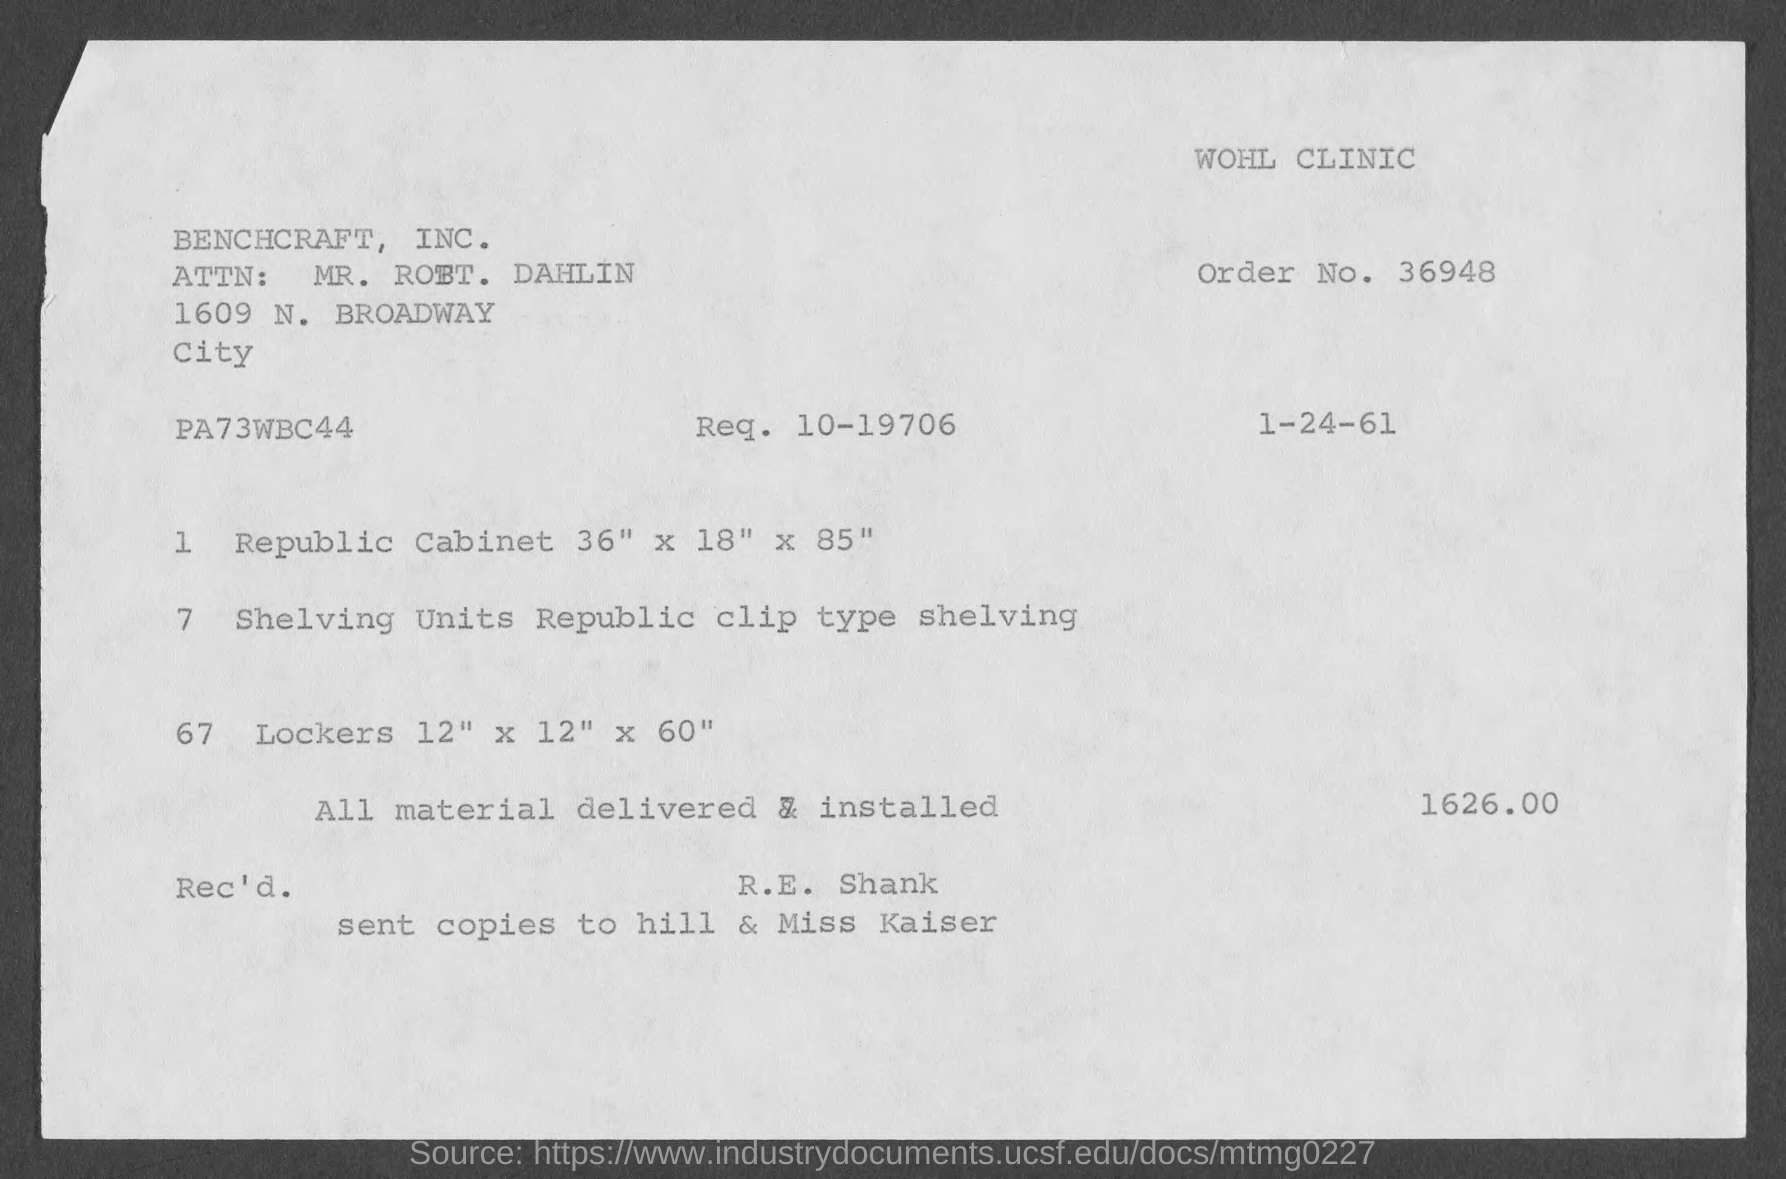What is the date mentioned in the invoice?
Give a very brief answer. 1-24-61. What is the Req. No. given in the invoice?
Your answer should be very brief. 10-19706. Which company is raising the invoice?
Offer a terse response. BENCHCRAFT, INC. What is the total invoice amount given?
Your response must be concise. 1626.00. What is the Order No. given in the invoice?
Keep it short and to the point. 36948. 